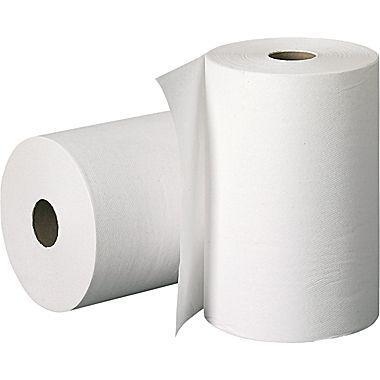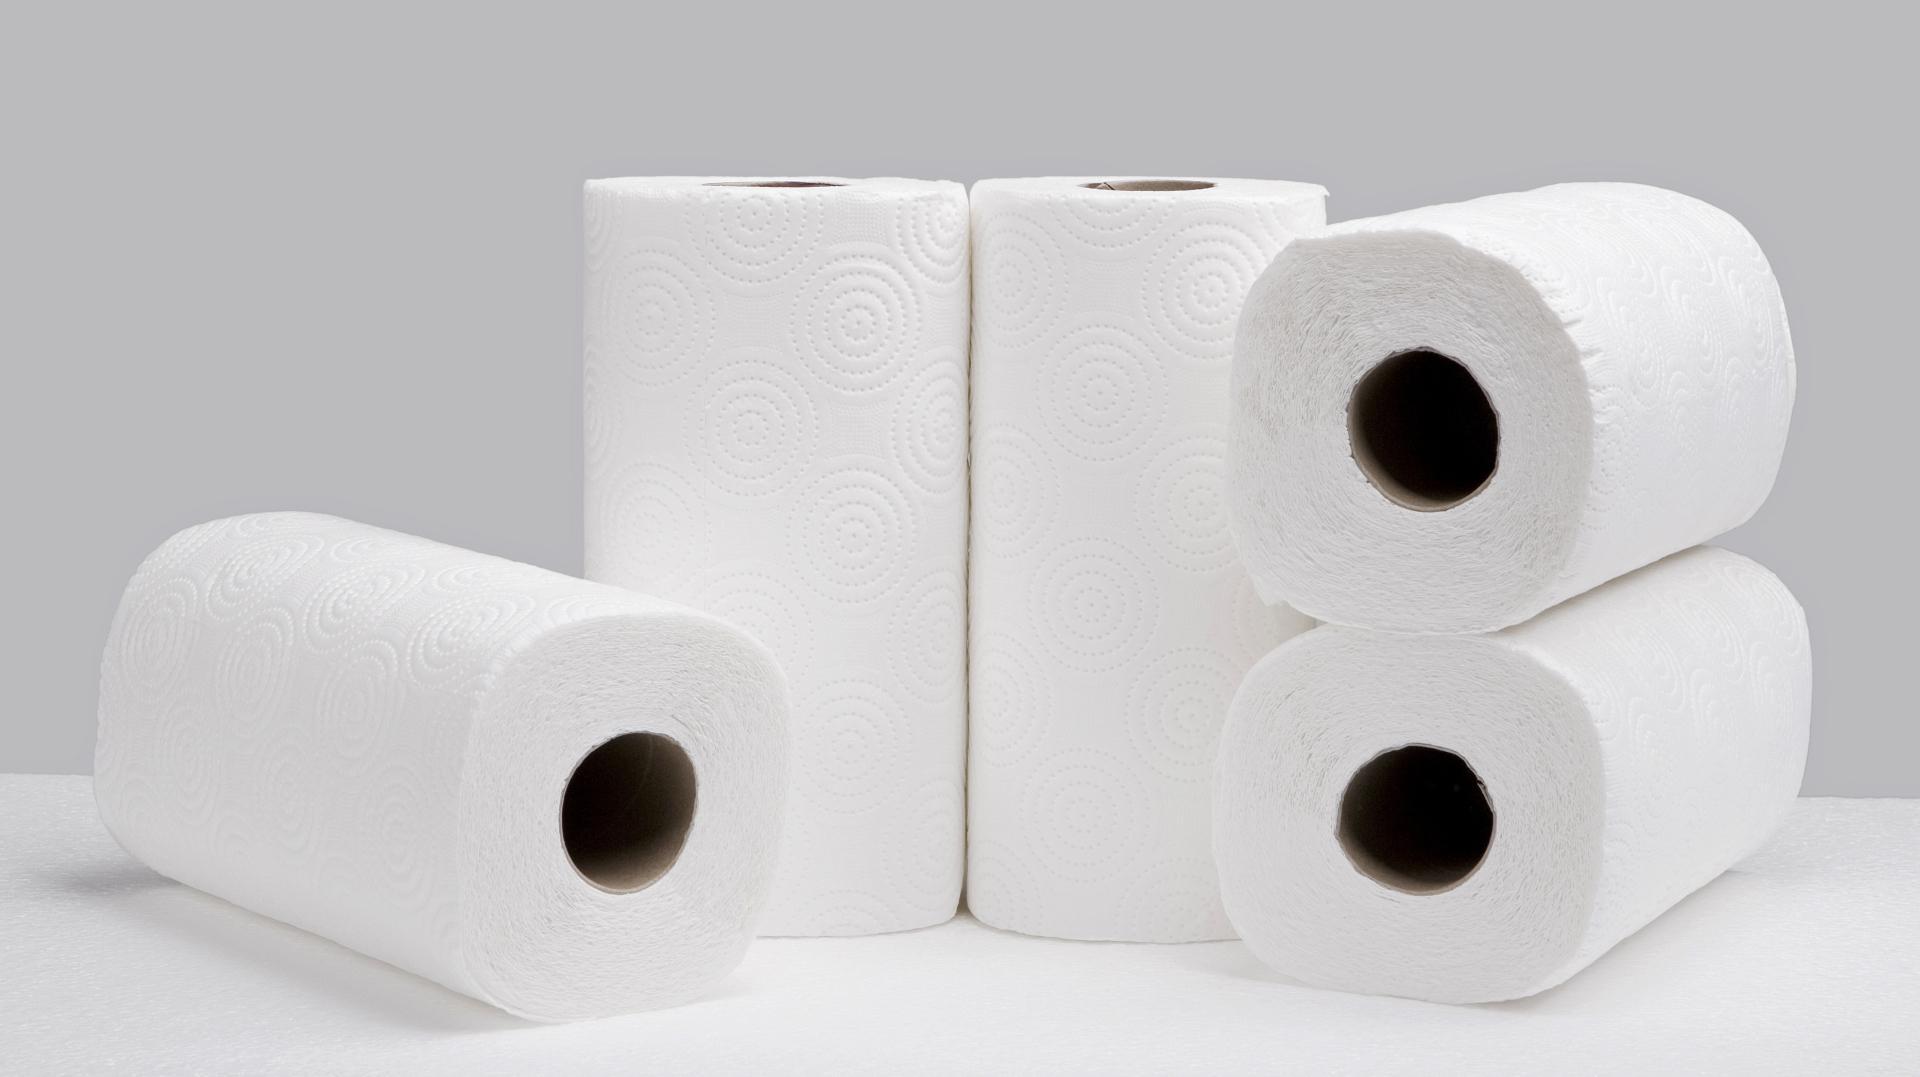The first image is the image on the left, the second image is the image on the right. Examine the images to the left and right. Is the description "One roll of tan and one roll of white paper towels are laying horizontally." accurate? Answer yes or no. No. The first image is the image on the left, the second image is the image on the right. For the images shown, is this caption "1 roll is unrolling from the top." true? Answer yes or no. No. 